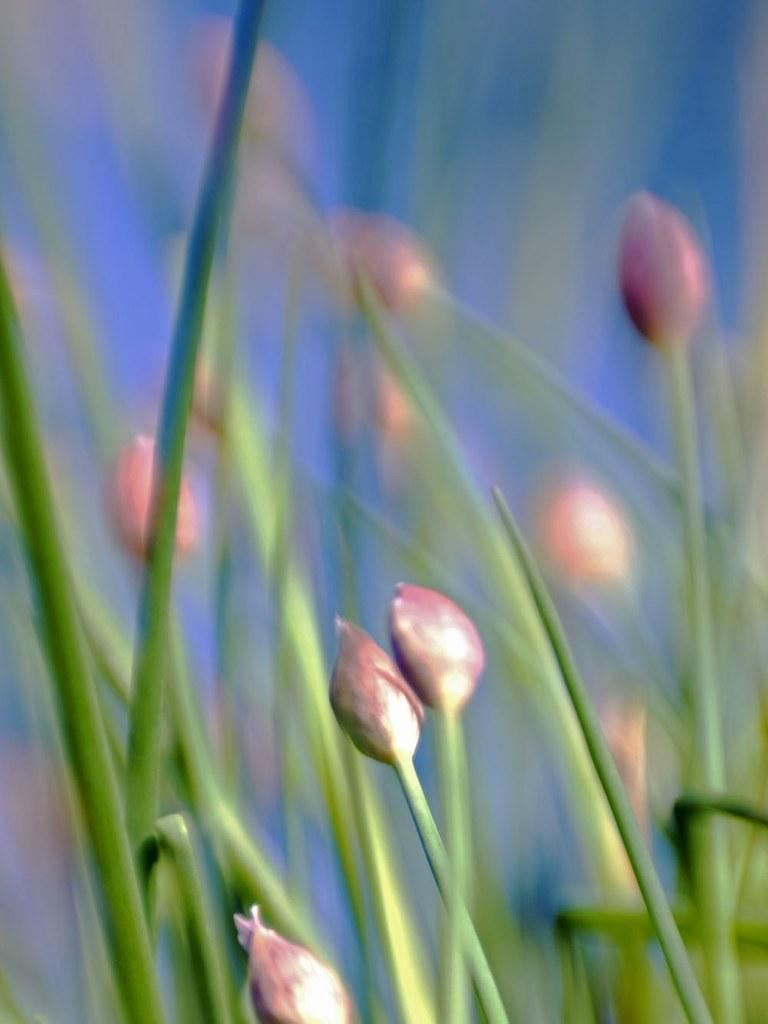What types of living organisms can be seen in the foreground of the image? Plants and flowers can be seen in the foreground of the image. What part of the natural environment is visible in the background of the image? The sky is visible in the background of the image. What type of company is responsible for the snake in the image? There is no snake present in the image, so it is not possible to determine which company might be responsible. 